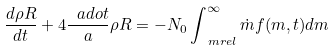<formula> <loc_0><loc_0><loc_500><loc_500>\frac { d \rho R } { d t } + 4 \frac { \ a d o t } { a } \rho R = - N _ { 0 } \int _ { \ m r e l } ^ { \infty } \dot { m } f ( m , t ) d m</formula> 